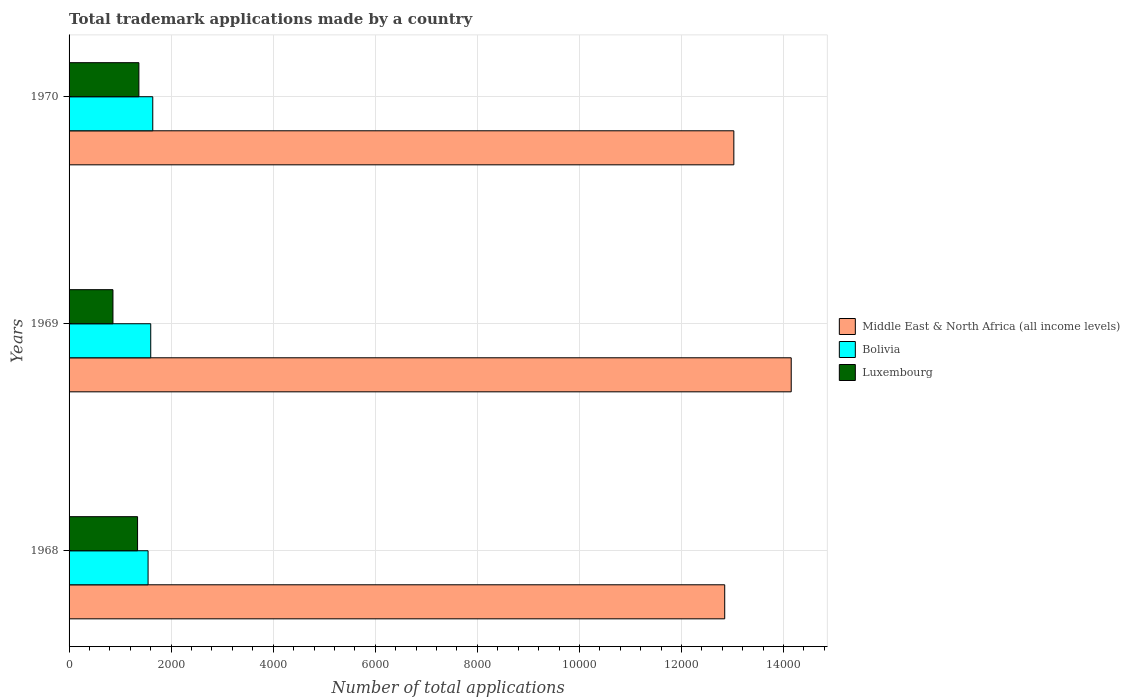How many different coloured bars are there?
Offer a very short reply. 3. Are the number of bars per tick equal to the number of legend labels?
Your answer should be very brief. Yes. How many bars are there on the 2nd tick from the top?
Offer a terse response. 3. How many bars are there on the 2nd tick from the bottom?
Your response must be concise. 3. What is the label of the 3rd group of bars from the top?
Ensure brevity in your answer.  1968. In how many cases, is the number of bars for a given year not equal to the number of legend labels?
Your answer should be compact. 0. What is the number of applications made by in Bolivia in 1969?
Make the answer very short. 1600. Across all years, what is the maximum number of applications made by in Bolivia?
Your answer should be very brief. 1640. Across all years, what is the minimum number of applications made by in Bolivia?
Provide a succinct answer. 1548. In which year was the number of applications made by in Middle East & North Africa (all income levels) minimum?
Your answer should be very brief. 1968. What is the total number of applications made by in Bolivia in the graph?
Make the answer very short. 4788. What is the difference between the number of applications made by in Bolivia in 1968 and that in 1969?
Your response must be concise. -52. What is the difference between the number of applications made by in Middle East & North Africa (all income levels) in 1970 and the number of applications made by in Luxembourg in 1969?
Your answer should be very brief. 1.22e+04. What is the average number of applications made by in Luxembourg per year?
Offer a very short reply. 1190. In the year 1968, what is the difference between the number of applications made by in Luxembourg and number of applications made by in Middle East & North Africa (all income levels)?
Provide a short and direct response. -1.15e+04. In how many years, is the number of applications made by in Middle East & North Africa (all income levels) greater than 12400 ?
Your answer should be compact. 3. What is the ratio of the number of applications made by in Luxembourg in 1969 to that in 1970?
Provide a succinct answer. 0.63. What is the difference between the highest and the second highest number of applications made by in Middle East & North Africa (all income levels)?
Your answer should be compact. 1124. What is the difference between the highest and the lowest number of applications made by in Luxembourg?
Provide a short and direct response. 508. In how many years, is the number of applications made by in Middle East & North Africa (all income levels) greater than the average number of applications made by in Middle East & North Africa (all income levels) taken over all years?
Provide a succinct answer. 1. What does the 1st bar from the top in 1968 represents?
Provide a succinct answer. Luxembourg. What does the 3rd bar from the bottom in 1970 represents?
Give a very brief answer. Luxembourg. How many years are there in the graph?
Keep it short and to the point. 3. What is the difference between two consecutive major ticks on the X-axis?
Make the answer very short. 2000. Does the graph contain grids?
Provide a succinct answer. Yes. Where does the legend appear in the graph?
Keep it short and to the point. Center right. What is the title of the graph?
Ensure brevity in your answer.  Total trademark applications made by a country. Does "Poland" appear as one of the legend labels in the graph?
Give a very brief answer. No. What is the label or title of the X-axis?
Offer a terse response. Number of total applications. What is the Number of total applications in Middle East & North Africa (all income levels) in 1968?
Offer a terse response. 1.28e+04. What is the Number of total applications in Bolivia in 1968?
Keep it short and to the point. 1548. What is the Number of total applications of Luxembourg in 1968?
Your answer should be very brief. 1342. What is the Number of total applications of Middle East & North Africa (all income levels) in 1969?
Provide a short and direct response. 1.42e+04. What is the Number of total applications of Bolivia in 1969?
Offer a very short reply. 1600. What is the Number of total applications in Luxembourg in 1969?
Your answer should be compact. 860. What is the Number of total applications in Middle East & North Africa (all income levels) in 1970?
Your answer should be compact. 1.30e+04. What is the Number of total applications in Bolivia in 1970?
Your response must be concise. 1640. What is the Number of total applications of Luxembourg in 1970?
Keep it short and to the point. 1368. Across all years, what is the maximum Number of total applications of Middle East & North Africa (all income levels)?
Offer a very short reply. 1.42e+04. Across all years, what is the maximum Number of total applications of Bolivia?
Keep it short and to the point. 1640. Across all years, what is the maximum Number of total applications of Luxembourg?
Offer a terse response. 1368. Across all years, what is the minimum Number of total applications of Middle East & North Africa (all income levels)?
Provide a succinct answer. 1.28e+04. Across all years, what is the minimum Number of total applications in Bolivia?
Offer a terse response. 1548. Across all years, what is the minimum Number of total applications of Luxembourg?
Keep it short and to the point. 860. What is the total Number of total applications in Middle East & North Africa (all income levels) in the graph?
Your answer should be compact. 4.00e+04. What is the total Number of total applications in Bolivia in the graph?
Your response must be concise. 4788. What is the total Number of total applications in Luxembourg in the graph?
Your response must be concise. 3570. What is the difference between the Number of total applications in Middle East & North Africa (all income levels) in 1968 and that in 1969?
Keep it short and to the point. -1303. What is the difference between the Number of total applications of Bolivia in 1968 and that in 1969?
Your response must be concise. -52. What is the difference between the Number of total applications in Luxembourg in 1968 and that in 1969?
Keep it short and to the point. 482. What is the difference between the Number of total applications in Middle East & North Africa (all income levels) in 1968 and that in 1970?
Ensure brevity in your answer.  -179. What is the difference between the Number of total applications in Bolivia in 1968 and that in 1970?
Your response must be concise. -92. What is the difference between the Number of total applications of Luxembourg in 1968 and that in 1970?
Provide a short and direct response. -26. What is the difference between the Number of total applications in Middle East & North Africa (all income levels) in 1969 and that in 1970?
Ensure brevity in your answer.  1124. What is the difference between the Number of total applications in Bolivia in 1969 and that in 1970?
Provide a succinct answer. -40. What is the difference between the Number of total applications of Luxembourg in 1969 and that in 1970?
Ensure brevity in your answer.  -508. What is the difference between the Number of total applications of Middle East & North Africa (all income levels) in 1968 and the Number of total applications of Bolivia in 1969?
Provide a short and direct response. 1.12e+04. What is the difference between the Number of total applications of Middle East & North Africa (all income levels) in 1968 and the Number of total applications of Luxembourg in 1969?
Offer a terse response. 1.20e+04. What is the difference between the Number of total applications of Bolivia in 1968 and the Number of total applications of Luxembourg in 1969?
Provide a short and direct response. 688. What is the difference between the Number of total applications of Middle East & North Africa (all income levels) in 1968 and the Number of total applications of Bolivia in 1970?
Give a very brief answer. 1.12e+04. What is the difference between the Number of total applications in Middle East & North Africa (all income levels) in 1968 and the Number of total applications in Luxembourg in 1970?
Provide a short and direct response. 1.15e+04. What is the difference between the Number of total applications of Bolivia in 1968 and the Number of total applications of Luxembourg in 1970?
Make the answer very short. 180. What is the difference between the Number of total applications of Middle East & North Africa (all income levels) in 1969 and the Number of total applications of Bolivia in 1970?
Ensure brevity in your answer.  1.25e+04. What is the difference between the Number of total applications of Middle East & North Africa (all income levels) in 1969 and the Number of total applications of Luxembourg in 1970?
Your answer should be compact. 1.28e+04. What is the difference between the Number of total applications in Bolivia in 1969 and the Number of total applications in Luxembourg in 1970?
Offer a terse response. 232. What is the average Number of total applications in Middle East & North Africa (all income levels) per year?
Offer a terse response. 1.33e+04. What is the average Number of total applications in Bolivia per year?
Keep it short and to the point. 1596. What is the average Number of total applications of Luxembourg per year?
Provide a succinct answer. 1190. In the year 1968, what is the difference between the Number of total applications of Middle East & North Africa (all income levels) and Number of total applications of Bolivia?
Your response must be concise. 1.13e+04. In the year 1968, what is the difference between the Number of total applications in Middle East & North Africa (all income levels) and Number of total applications in Luxembourg?
Your answer should be very brief. 1.15e+04. In the year 1968, what is the difference between the Number of total applications of Bolivia and Number of total applications of Luxembourg?
Your answer should be compact. 206. In the year 1969, what is the difference between the Number of total applications in Middle East & North Africa (all income levels) and Number of total applications in Bolivia?
Provide a short and direct response. 1.26e+04. In the year 1969, what is the difference between the Number of total applications of Middle East & North Africa (all income levels) and Number of total applications of Luxembourg?
Offer a very short reply. 1.33e+04. In the year 1969, what is the difference between the Number of total applications of Bolivia and Number of total applications of Luxembourg?
Your response must be concise. 740. In the year 1970, what is the difference between the Number of total applications of Middle East & North Africa (all income levels) and Number of total applications of Bolivia?
Provide a succinct answer. 1.14e+04. In the year 1970, what is the difference between the Number of total applications in Middle East & North Africa (all income levels) and Number of total applications in Luxembourg?
Provide a short and direct response. 1.17e+04. In the year 1970, what is the difference between the Number of total applications of Bolivia and Number of total applications of Luxembourg?
Offer a very short reply. 272. What is the ratio of the Number of total applications in Middle East & North Africa (all income levels) in 1968 to that in 1969?
Make the answer very short. 0.91. What is the ratio of the Number of total applications in Bolivia in 1968 to that in 1969?
Give a very brief answer. 0.97. What is the ratio of the Number of total applications in Luxembourg in 1968 to that in 1969?
Your response must be concise. 1.56. What is the ratio of the Number of total applications in Middle East & North Africa (all income levels) in 1968 to that in 1970?
Provide a short and direct response. 0.99. What is the ratio of the Number of total applications in Bolivia in 1968 to that in 1970?
Ensure brevity in your answer.  0.94. What is the ratio of the Number of total applications of Middle East & North Africa (all income levels) in 1969 to that in 1970?
Offer a terse response. 1.09. What is the ratio of the Number of total applications of Bolivia in 1969 to that in 1970?
Provide a short and direct response. 0.98. What is the ratio of the Number of total applications in Luxembourg in 1969 to that in 1970?
Offer a very short reply. 0.63. What is the difference between the highest and the second highest Number of total applications in Middle East & North Africa (all income levels)?
Provide a succinct answer. 1124. What is the difference between the highest and the second highest Number of total applications of Bolivia?
Give a very brief answer. 40. What is the difference between the highest and the lowest Number of total applications of Middle East & North Africa (all income levels)?
Provide a succinct answer. 1303. What is the difference between the highest and the lowest Number of total applications in Bolivia?
Keep it short and to the point. 92. What is the difference between the highest and the lowest Number of total applications of Luxembourg?
Offer a very short reply. 508. 